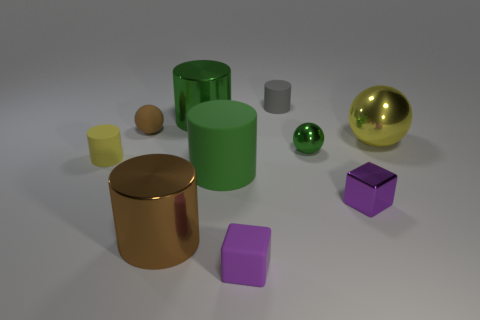The shiny block that is the same color as the tiny rubber cube is what size?
Make the answer very short. Small. There is a yellow thing that is on the left side of the small green metal object; what size is it?
Offer a very short reply. Small. There is a purple thing to the right of the tiny cylinder that is behind the tiny matte ball left of the tiny green sphere; what size is it?
Provide a succinct answer. Small. What color is the cylinder that is to the left of the big brown cylinder?
Make the answer very short. Yellow. There is a large matte object that is the same color as the small metal sphere; what shape is it?
Make the answer very short. Cylinder. There is a big green object that is in front of the small yellow thing; what shape is it?
Keep it short and to the point. Cylinder. What number of green objects are either metal balls or big matte things?
Your answer should be compact. 2. Is the brown cylinder made of the same material as the tiny gray cylinder?
Your response must be concise. No. There is a small purple metallic block; what number of cylinders are in front of it?
Provide a short and direct response. 1. There is a thing that is on the left side of the brown cylinder and in front of the tiny brown object; what material is it?
Ensure brevity in your answer.  Rubber. 